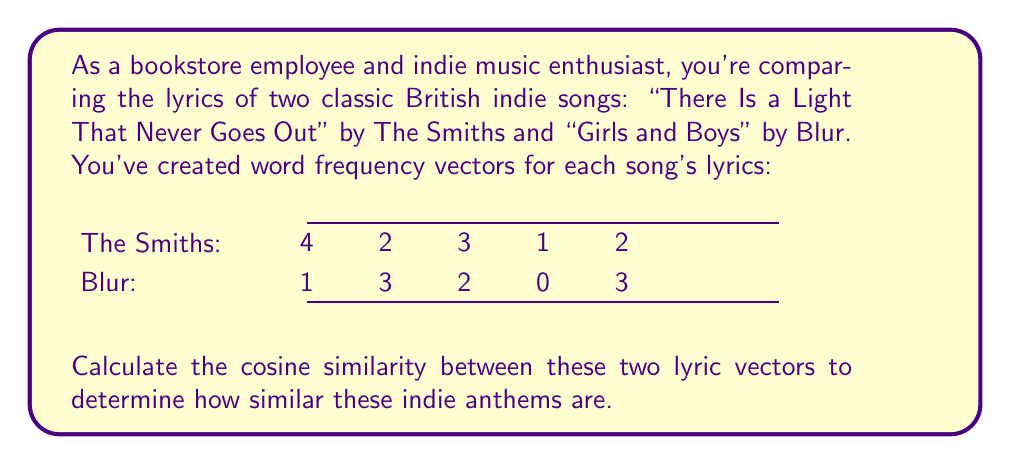Solve this math problem. Let's approach this step-by-step:

1) The cosine similarity formula is:

   $$\text{cosine similarity} = \frac{\mathbf{A} \cdot \mathbf{B}}{\|\mathbf{A}\| \|\mathbf{B}\|}$$

   Where $\mathbf{A}$ and $\mathbf{B}$ are the vectors, $\cdot$ denotes dot product, and $\|\mathbf{A}\|$ is the magnitude of vector $\mathbf{A}$.

2) First, let's calculate the dot product $\mathbf{A} \cdot \mathbf{B}$:
   
   $(4 \times 1) + (2 \times 3) + (3 \times 2) + (1 \times 0) + (2 \times 3) = 4 + 6 + 6 + 0 + 6 = 22$

3) Now, we need to calculate the magnitudes:

   $\|\mathbf{A}\| = \sqrt{4^2 + 2^2 + 3^2 + 1^2 + 2^2} = \sqrt{16 + 4 + 9 + 1 + 4} = \sqrt{34}$
   
   $\|\mathbf{B}\| = \sqrt{1^2 + 3^2 + 2^2 + 0^2 + 3^2} = \sqrt{1 + 9 + 4 + 0 + 9} = \sqrt{23}$

4) Now we can plug these values into our formula:

   $$\text{cosine similarity} = \frac{22}{\sqrt{34} \times \sqrt{23}}$$

5) Simplifying:

   $$\text{cosine similarity} = \frac{22}{\sqrt{782}} \approx 0.7868$$
Answer: 0.7868 